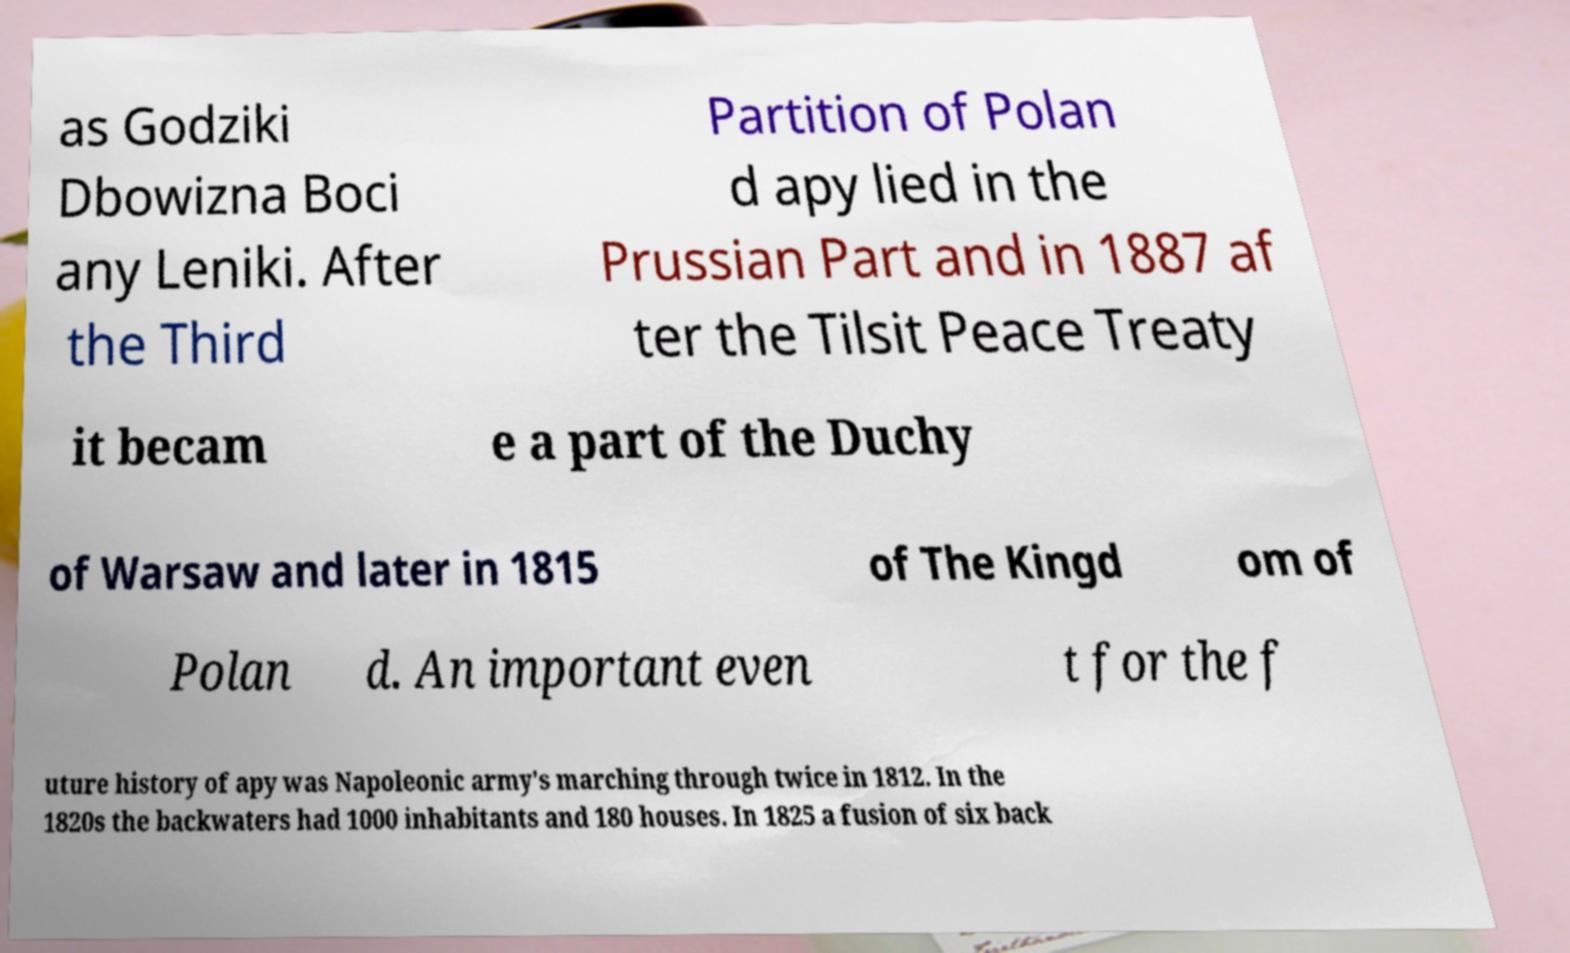Could you assist in decoding the text presented in this image and type it out clearly? as Godziki Dbowizna Boci any Leniki. After the Third Partition of Polan d apy lied in the Prussian Part and in 1887 af ter the Tilsit Peace Treaty it becam e a part of the Duchy of Warsaw and later in 1815 of The Kingd om of Polan d. An important even t for the f uture history of apy was Napoleonic army's marching through twice in 1812. In the 1820s the backwaters had 1000 inhabitants and 180 houses. In 1825 a fusion of six back 